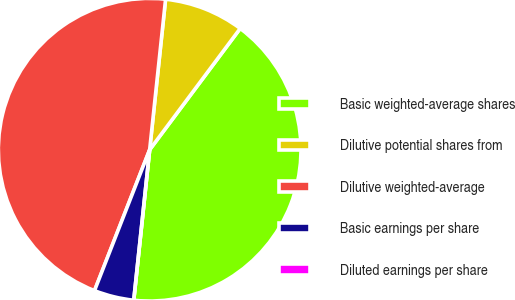<chart> <loc_0><loc_0><loc_500><loc_500><pie_chart><fcel>Basic weighted-average shares<fcel>Dilutive potential shares from<fcel>Dilutive weighted-average<fcel>Basic earnings per share<fcel>Diluted earnings per share<nl><fcel>41.47%<fcel>8.53%<fcel>45.74%<fcel>4.26%<fcel>0.0%<nl></chart> 